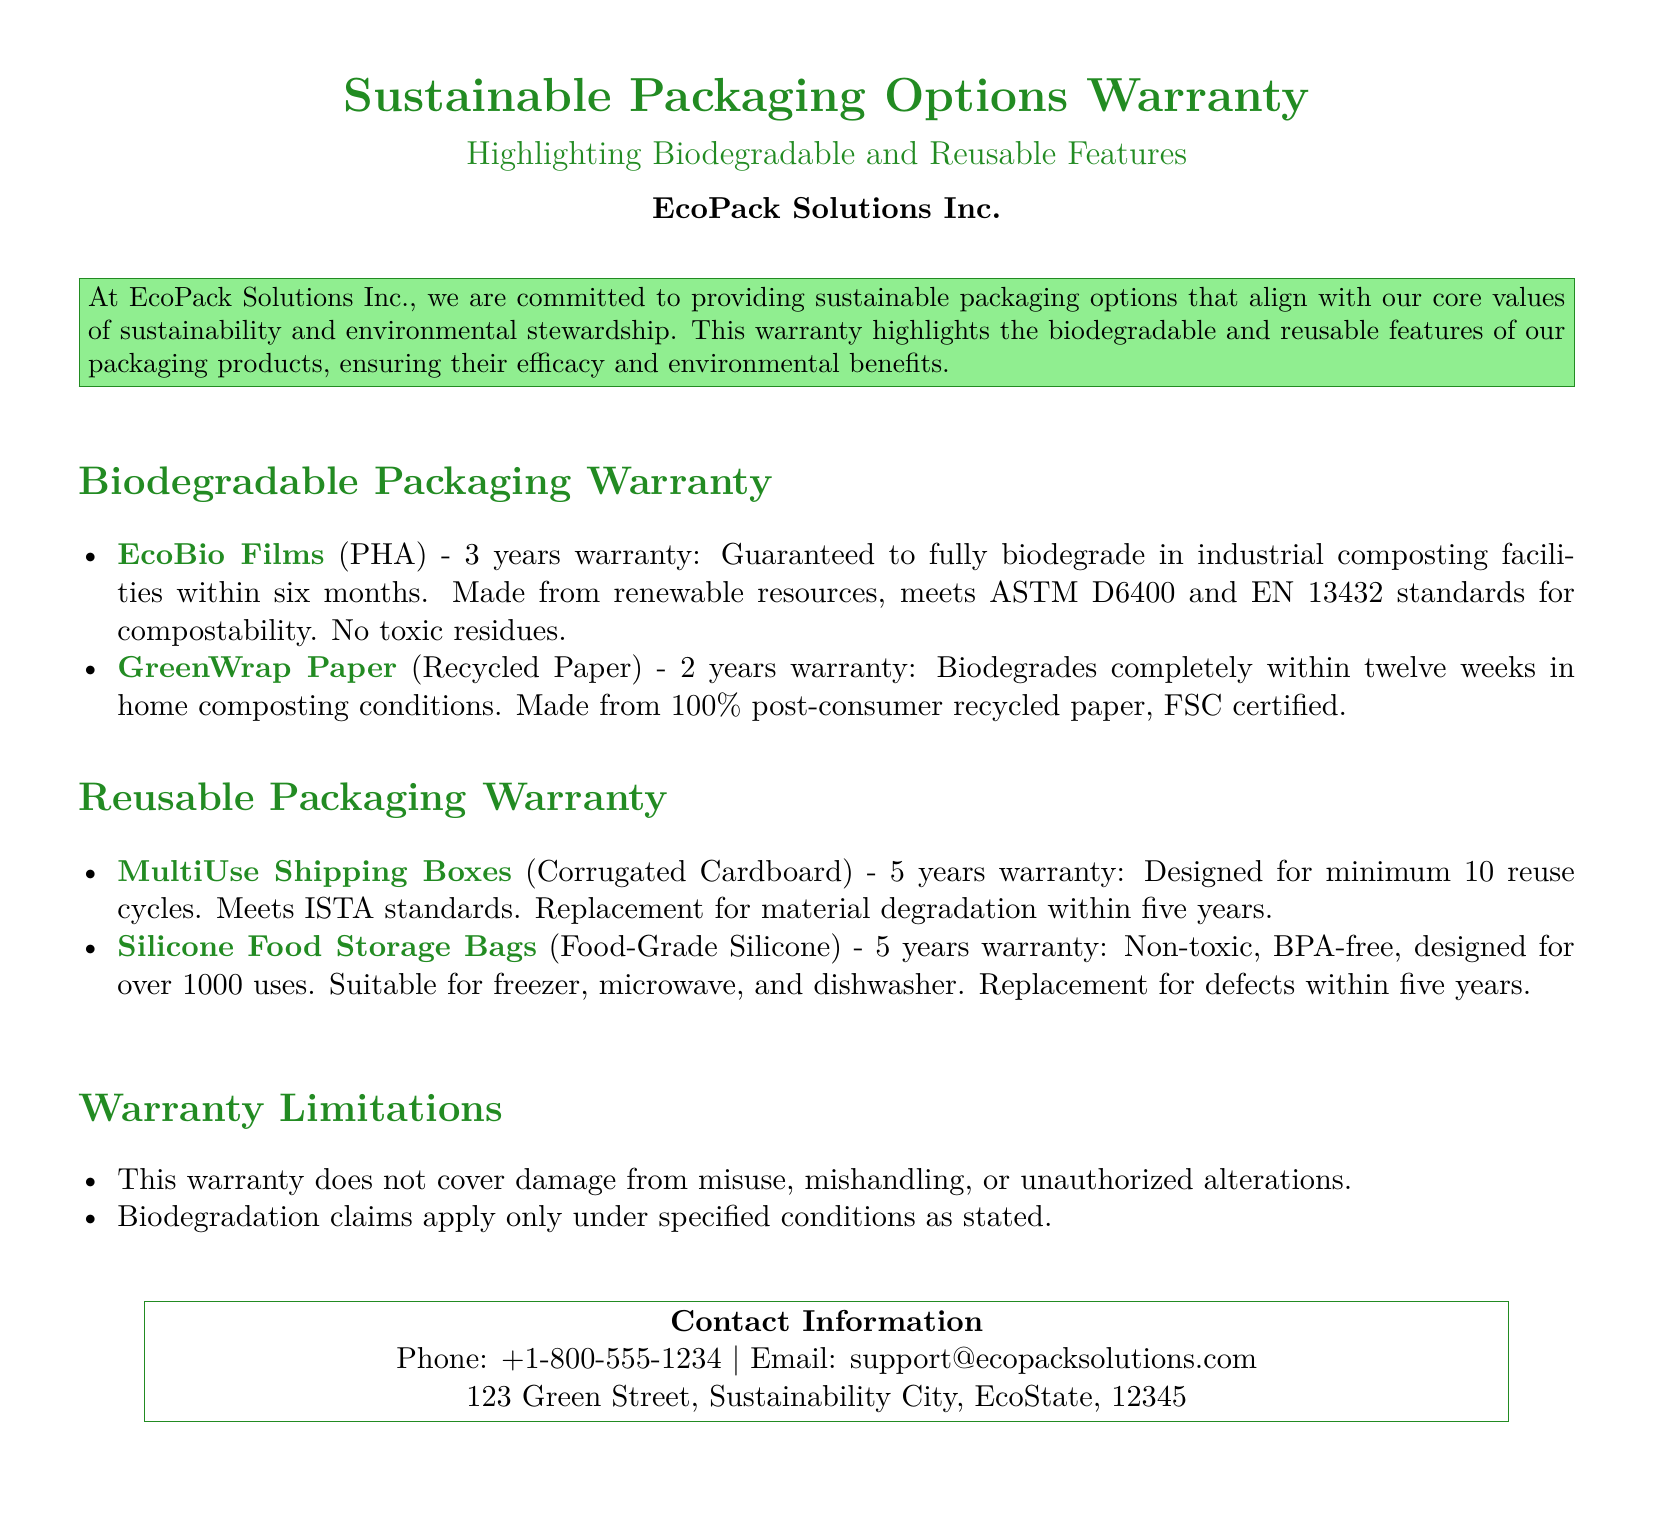What is the warranty period for EcoBio Films? The warranty period for EcoBio Films is stated in the document, which is 3 years.
Answer: 3 years What standards do EcoBio Films meet? The standards for EcoBio Films are specified in the document, which are ASTM D6400 and EN 13432.
Answer: ASTM D6400 and EN 13432 How many reuse cycles are MultiUse Shipping Boxes designed for? The document specifies that MultiUse Shipping Boxes are designed for a minimum of 10 reuse cycles.
Answer: 10 reuse cycles What is the biodegradation time for GreenWrap Paper in home composting conditions? The document mentions that GreenWrap Paper biodegrades completely within twelve weeks in home composting conditions.
Answer: twelve weeks What type of material are Silicone Food Storage Bags made from? The document clearly specifies that Silicone Food Storage Bags are made from food-grade silicone.
Answer: Food-Grade Silicone What limitations does the warranty have? The document lists limitations, one of which includes that the warranty does not cover damage from misuse or mishandling.
Answer: Damage from misuse or mishandling How long is the warranty for Silicone Food Storage Bags? The warranty period for Silicone Food Storage Bags is explicitly mentioned in the document as 5 years.
Answer: 5 years Which product contains 100% post-consumer recycled paper? GreenWrap Paper is mentioned in the document as being made from 100% post-consumer recycled paper.
Answer: GreenWrap Paper What contact method is provided for support? The document provides an email address for support, which is support@ecopacksolutions.com.
Answer: support@ecopacksolutions.com 